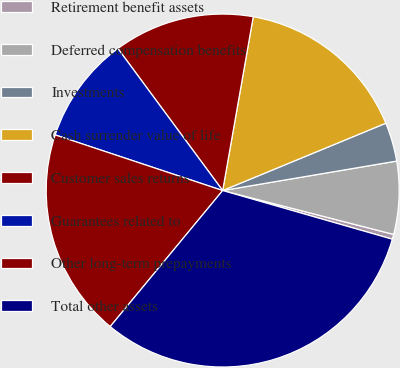Convert chart. <chart><loc_0><loc_0><loc_500><loc_500><pie_chart><fcel>Retirement benefit assets<fcel>Deferred compensation benefits<fcel>Investments<fcel>Cash surrender value of life<fcel>Customer sales returns<fcel>Guarantees related to<fcel>Other long-term prepayments<fcel>Total other assets<nl><fcel>0.45%<fcel>6.67%<fcel>3.56%<fcel>16.0%<fcel>12.89%<fcel>9.78%<fcel>19.11%<fcel>31.55%<nl></chart> 